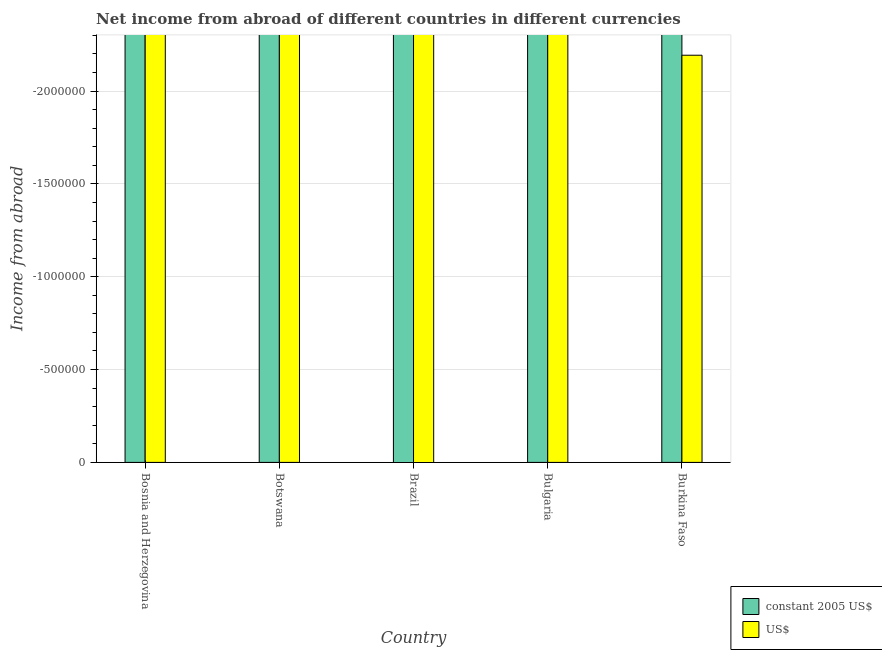How many different coloured bars are there?
Keep it short and to the point. 0. What is the label of the 3rd group of bars from the left?
Provide a succinct answer. Brazil. What is the total income from abroad in constant 2005 us$ in the graph?
Provide a short and direct response. 0. What is the difference between the income from abroad in constant 2005 us$ in Burkina Faso and the income from abroad in us$ in Bosnia and Herzegovina?
Your answer should be compact. 0. What is the difference between two consecutive major ticks on the Y-axis?
Offer a terse response. 5.00e+05. Does the graph contain grids?
Provide a short and direct response. Yes. Where does the legend appear in the graph?
Offer a terse response. Bottom right. How are the legend labels stacked?
Keep it short and to the point. Vertical. What is the title of the graph?
Your response must be concise. Net income from abroad of different countries in different currencies. Does "By country of origin" appear as one of the legend labels in the graph?
Provide a short and direct response. No. What is the label or title of the Y-axis?
Offer a very short reply. Income from abroad. What is the Income from abroad in constant 2005 US$ in Bosnia and Herzegovina?
Give a very brief answer. 0. What is the Income from abroad in constant 2005 US$ in Botswana?
Make the answer very short. 0. What is the Income from abroad in US$ in Botswana?
Your answer should be very brief. 0. What is the Income from abroad in US$ in Brazil?
Offer a very short reply. 0. What is the Income from abroad of constant 2005 US$ in Bulgaria?
Offer a very short reply. 0. What is the Income from abroad in US$ in Bulgaria?
Your answer should be compact. 0. What is the Income from abroad in constant 2005 US$ in Burkina Faso?
Provide a short and direct response. 0. What is the Income from abroad in US$ in Burkina Faso?
Your answer should be very brief. 0. What is the total Income from abroad of US$ in the graph?
Provide a short and direct response. 0. 